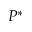<formula> <loc_0><loc_0><loc_500><loc_500>P ^ { * }</formula> 